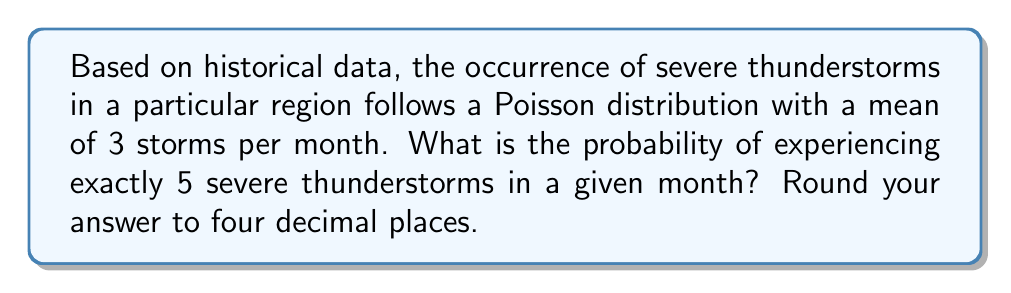Solve this math problem. To solve this problem, we'll use the Poisson probability mass function:

$$P(X = k) = \frac{e^{-\lambda} \lambda^k}{k!}$$

Where:
$\lambda$ = mean number of events in the given interval
$k$ = number of events we're calculating the probability for
$e$ = Euler's number (approximately 2.71828)

Given:
$\lambda = 3$ (mean of 3 storms per month)
$k = 5$ (we're calculating the probability of exactly 5 storms)

Step 1: Substitute the values into the Poisson formula:

$$P(X = 5) = \frac{e^{-3} 3^5}{5!}$$

Step 2: Calculate $3^5$:
$$3^5 = 243$$

Step 3: Calculate $5!$:
$$5! = 5 \times 4 \times 3 \times 2 \times 1 = 120$$

Step 4: Substitute these values and calculate:

$$P(X = 5) = \frac{e^{-3} \times 243}{120}$$

Step 5: Use a calculator to compute $e^{-3}$ and complete the calculation:

$$P(X = 5) = \frac{0.0497871 \times 243}{120} = 0.100719$$

Step 6: Round to four decimal places:

$$P(X = 5) \approx 0.1007$$
Answer: 0.1007 